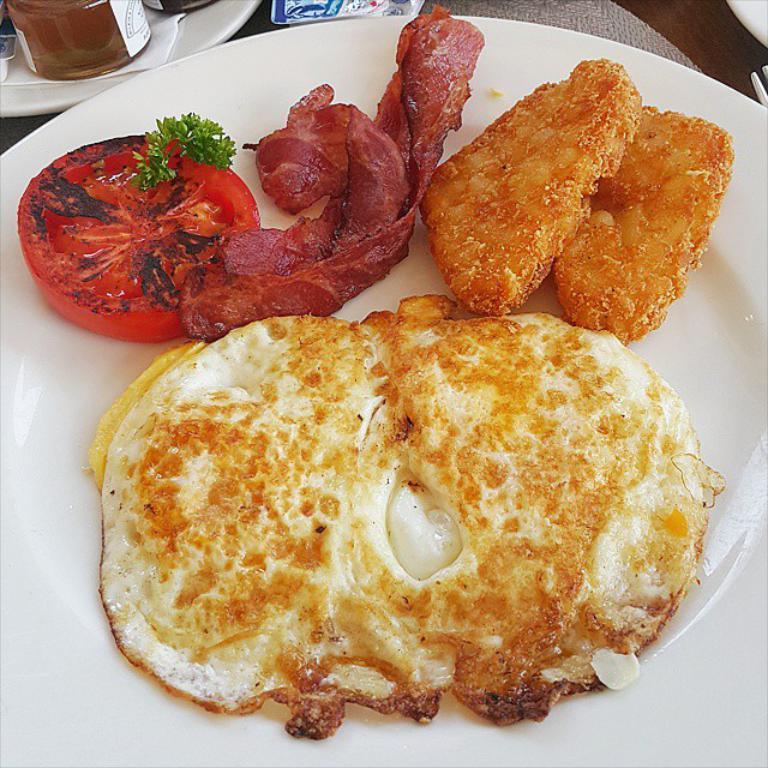In one or two sentences, can you explain what this image depicts? In this image we can see some food in a plate which is placed the surface. We can also see a bottle and tissue papers in a plate and a fork which are placed beside it. 